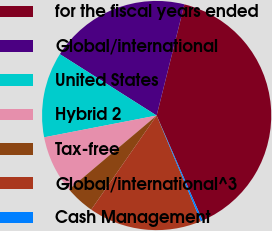<chart> <loc_0><loc_0><loc_500><loc_500><pie_chart><fcel>for the fiscal years ended<fcel>Global/international<fcel>United States<fcel>Hybrid 2<fcel>Tax-free<fcel>Global/international^3<fcel>Cash Management<nl><fcel>39.54%<fcel>19.9%<fcel>12.04%<fcel>8.11%<fcel>4.18%<fcel>15.97%<fcel>0.26%<nl></chart> 